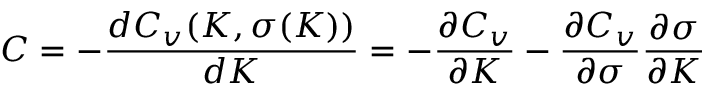<formula> <loc_0><loc_0><loc_500><loc_500>C = - { \frac { d C _ { v } ( K , \sigma ( K ) ) } { d K } } = - { \frac { \partial C _ { v } } { \partial K } } - { \frac { \partial C _ { v } } { \partial \sigma } } { \frac { \partial \sigma } { \partial K } }</formula> 